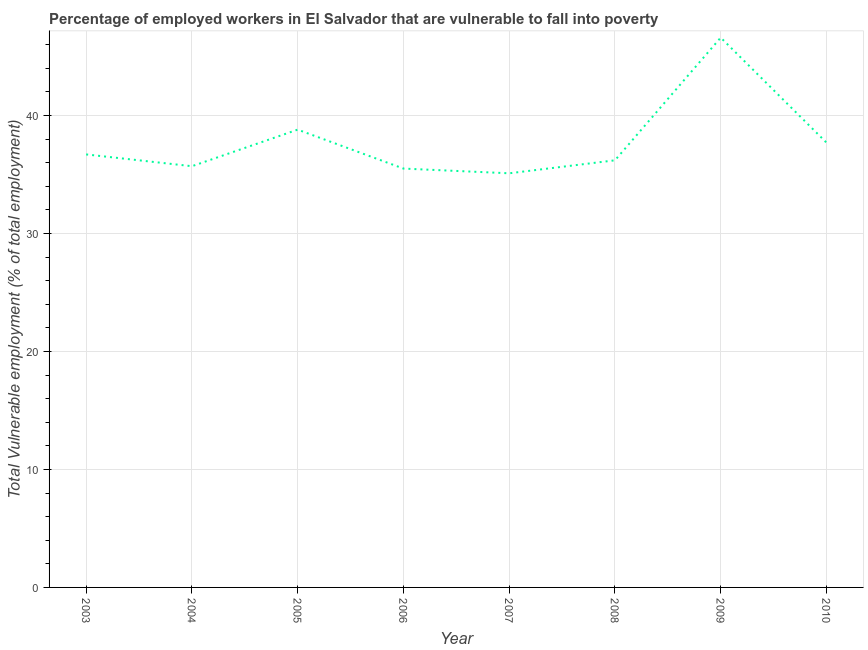What is the total vulnerable employment in 2010?
Provide a succinct answer. 37.7. Across all years, what is the maximum total vulnerable employment?
Provide a succinct answer. 46.6. Across all years, what is the minimum total vulnerable employment?
Provide a succinct answer. 35.1. In which year was the total vulnerable employment maximum?
Your response must be concise. 2009. What is the sum of the total vulnerable employment?
Provide a short and direct response. 302.3. What is the difference between the total vulnerable employment in 2009 and 2010?
Your answer should be compact. 8.9. What is the average total vulnerable employment per year?
Offer a terse response. 37.79. What is the median total vulnerable employment?
Your answer should be compact. 36.45. Do a majority of the years between 2010 and 2009 (inclusive) have total vulnerable employment greater than 44 %?
Your answer should be compact. No. What is the ratio of the total vulnerable employment in 2003 to that in 2008?
Give a very brief answer. 1.01. Is the total vulnerable employment in 2005 less than that in 2006?
Offer a terse response. No. Is the difference between the total vulnerable employment in 2003 and 2007 greater than the difference between any two years?
Ensure brevity in your answer.  No. What is the difference between the highest and the second highest total vulnerable employment?
Your answer should be very brief. 7.8. Is the sum of the total vulnerable employment in 2004 and 2006 greater than the maximum total vulnerable employment across all years?
Ensure brevity in your answer.  Yes. What is the difference between the highest and the lowest total vulnerable employment?
Offer a very short reply. 11.5. In how many years, is the total vulnerable employment greater than the average total vulnerable employment taken over all years?
Give a very brief answer. 2. Does the total vulnerable employment monotonically increase over the years?
Ensure brevity in your answer.  No. How many lines are there?
Your answer should be very brief. 1. What is the difference between two consecutive major ticks on the Y-axis?
Offer a very short reply. 10. Does the graph contain grids?
Your response must be concise. Yes. What is the title of the graph?
Offer a terse response. Percentage of employed workers in El Salvador that are vulnerable to fall into poverty. What is the label or title of the Y-axis?
Offer a very short reply. Total Vulnerable employment (% of total employment). What is the Total Vulnerable employment (% of total employment) in 2003?
Give a very brief answer. 36.7. What is the Total Vulnerable employment (% of total employment) of 2004?
Make the answer very short. 35.7. What is the Total Vulnerable employment (% of total employment) of 2005?
Offer a very short reply. 38.8. What is the Total Vulnerable employment (% of total employment) of 2006?
Provide a short and direct response. 35.5. What is the Total Vulnerable employment (% of total employment) of 2007?
Offer a very short reply. 35.1. What is the Total Vulnerable employment (% of total employment) in 2008?
Offer a terse response. 36.2. What is the Total Vulnerable employment (% of total employment) of 2009?
Offer a terse response. 46.6. What is the Total Vulnerable employment (% of total employment) in 2010?
Ensure brevity in your answer.  37.7. What is the difference between the Total Vulnerable employment (% of total employment) in 2003 and 2007?
Offer a very short reply. 1.6. What is the difference between the Total Vulnerable employment (% of total employment) in 2003 and 2010?
Make the answer very short. -1. What is the difference between the Total Vulnerable employment (% of total employment) in 2004 and 2009?
Provide a succinct answer. -10.9. What is the difference between the Total Vulnerable employment (% of total employment) in 2004 and 2010?
Provide a short and direct response. -2. What is the difference between the Total Vulnerable employment (% of total employment) in 2005 and 2006?
Your answer should be very brief. 3.3. What is the difference between the Total Vulnerable employment (% of total employment) in 2005 and 2007?
Your answer should be very brief. 3.7. What is the difference between the Total Vulnerable employment (% of total employment) in 2005 and 2009?
Give a very brief answer. -7.8. What is the difference between the Total Vulnerable employment (% of total employment) in 2006 and 2008?
Offer a terse response. -0.7. What is the difference between the Total Vulnerable employment (% of total employment) in 2006 and 2009?
Ensure brevity in your answer.  -11.1. What is the difference between the Total Vulnerable employment (% of total employment) in 2006 and 2010?
Ensure brevity in your answer.  -2.2. What is the difference between the Total Vulnerable employment (% of total employment) in 2007 and 2008?
Keep it short and to the point. -1.1. What is the difference between the Total Vulnerable employment (% of total employment) in 2007 and 2009?
Offer a terse response. -11.5. What is the difference between the Total Vulnerable employment (% of total employment) in 2007 and 2010?
Offer a very short reply. -2.6. What is the ratio of the Total Vulnerable employment (% of total employment) in 2003 to that in 2004?
Your response must be concise. 1.03. What is the ratio of the Total Vulnerable employment (% of total employment) in 2003 to that in 2005?
Ensure brevity in your answer.  0.95. What is the ratio of the Total Vulnerable employment (% of total employment) in 2003 to that in 2006?
Ensure brevity in your answer.  1.03. What is the ratio of the Total Vulnerable employment (% of total employment) in 2003 to that in 2007?
Offer a very short reply. 1.05. What is the ratio of the Total Vulnerable employment (% of total employment) in 2003 to that in 2009?
Your response must be concise. 0.79. What is the ratio of the Total Vulnerable employment (% of total employment) in 2004 to that in 2007?
Ensure brevity in your answer.  1.02. What is the ratio of the Total Vulnerable employment (% of total employment) in 2004 to that in 2009?
Offer a very short reply. 0.77. What is the ratio of the Total Vulnerable employment (% of total employment) in 2004 to that in 2010?
Give a very brief answer. 0.95. What is the ratio of the Total Vulnerable employment (% of total employment) in 2005 to that in 2006?
Give a very brief answer. 1.09. What is the ratio of the Total Vulnerable employment (% of total employment) in 2005 to that in 2007?
Offer a very short reply. 1.1. What is the ratio of the Total Vulnerable employment (% of total employment) in 2005 to that in 2008?
Your answer should be compact. 1.07. What is the ratio of the Total Vulnerable employment (% of total employment) in 2005 to that in 2009?
Offer a very short reply. 0.83. What is the ratio of the Total Vulnerable employment (% of total employment) in 2006 to that in 2009?
Your answer should be very brief. 0.76. What is the ratio of the Total Vulnerable employment (% of total employment) in 2006 to that in 2010?
Ensure brevity in your answer.  0.94. What is the ratio of the Total Vulnerable employment (% of total employment) in 2007 to that in 2009?
Offer a terse response. 0.75. What is the ratio of the Total Vulnerable employment (% of total employment) in 2008 to that in 2009?
Provide a short and direct response. 0.78. What is the ratio of the Total Vulnerable employment (% of total employment) in 2008 to that in 2010?
Provide a short and direct response. 0.96. What is the ratio of the Total Vulnerable employment (% of total employment) in 2009 to that in 2010?
Offer a terse response. 1.24. 